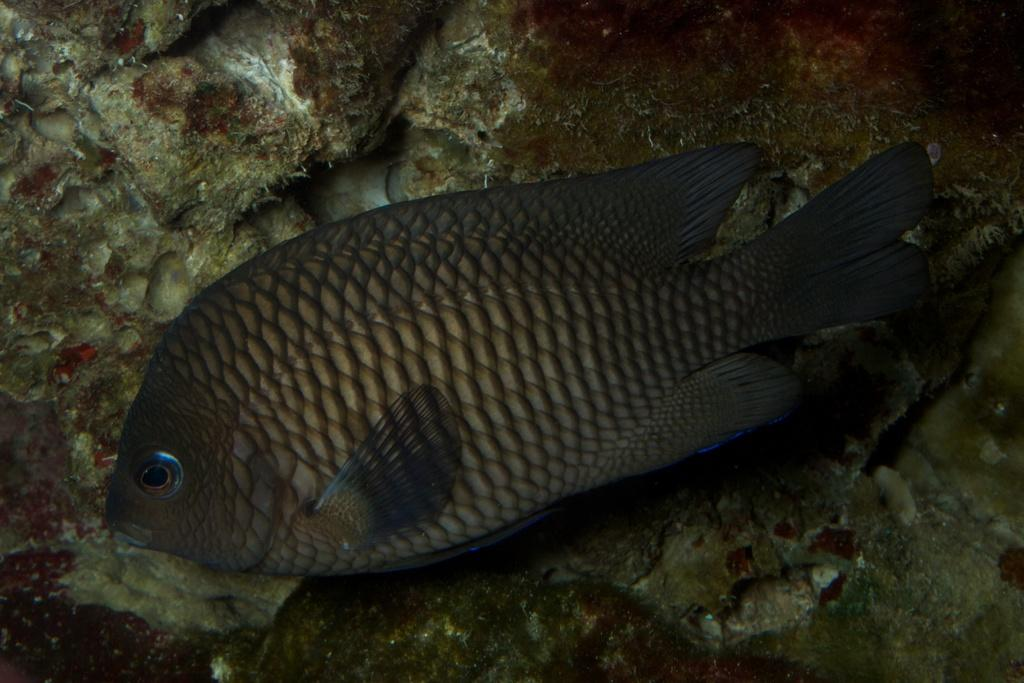What type of animals can be seen on the surface in the image? There are fish on the surface in the image. Can you describe the location or environment where the fish are found? The provided facts do not specify the location or environment where the fish are found. How many fish can be seen on the surface? The provided facts do not specify the number of fish on the surface. What language is being spoken by the fish in the image? There is no indication in the image that the fish are speaking any language. 